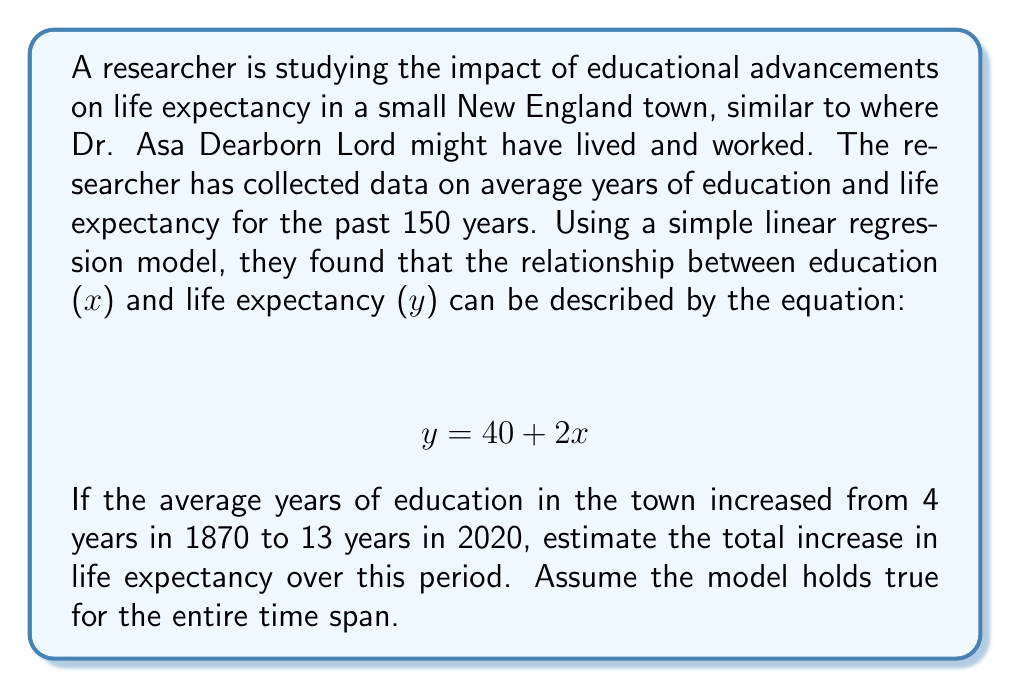Provide a solution to this math problem. To solve this problem, we'll follow these steps:

1) First, let's calculate the life expectancy for 1870 and 2020 using the given equation:
   $$ y = 40 + 2x $$

   For 1870 (x = 4):
   $$ y_{1870} = 40 + 2(4) = 40 + 8 = 48 \text{ years} $$

   For 2020 (x = 13):
   $$ y_{2020} = 40 + 2(13) = 40 + 26 = 66 \text{ years} $$

2) Now, we can calculate the increase in life expectancy by subtracting:
   $$ \text{Increase} = y_{2020} - y_{1870} = 66 - 48 = 18 \text{ years} $$

This result suggests that, according to the model, the increase in average years of education from 4 to 13 years over the 150-year period corresponded to an increase in life expectancy of 18 years.

It's important to note that this is a simplified model and assumes a linear relationship between education and life expectancy over a long period. In reality, many other factors would influence life expectancy, and the relationship might not be strictly linear. However, this model provides a basic estimate of the potential impact of educational advancements on life expectancy in this historical context.
Answer: 18 years 